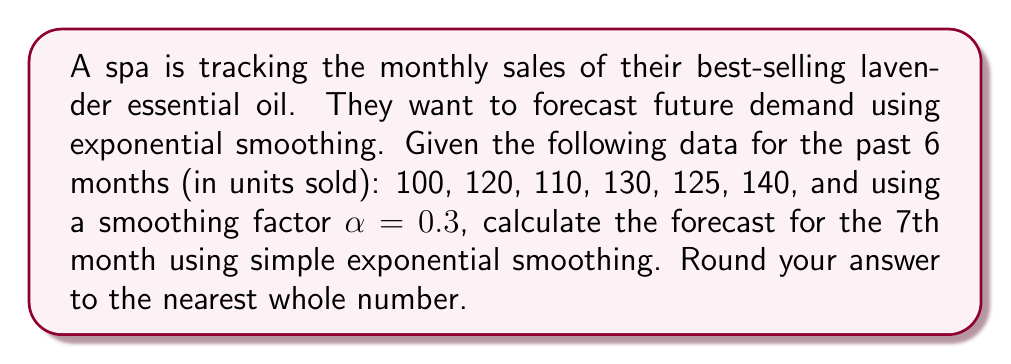What is the answer to this math problem? To forecast future demand using simple exponential smoothing, we use the formula:

$$F_{t+1} = \alpha Y_t + (1-\alpha)F_t$$

Where:
$F_{t+1}$ is the forecast for the next period
$\alpha$ is the smoothing factor (0.3 in this case)
$Y_t$ is the actual value for the current period
$F_t$ is the forecast for the current period

Step 1: Initialize the forecast
We'll use the first actual value as our initial forecast:
$F_1 = 100$

Step 2: Calculate subsequent forecasts
$F_2 = 0.3(100) + 0.7(100) = 100$
$F_3 = 0.3(120) + 0.7(100) = 106$
$F_4 = 0.3(110) + 0.7(106) = 107.2$
$F_5 = 0.3(130) + 0.7(107.2) = 114.04$
$F_6 = 0.3(125) + 0.7(114.04) = 117.328$

Step 3: Calculate the forecast for the 7th month
$F_7 = 0.3(140) + 0.7(117.328) = 124.1296$

Step 4: Round to the nearest whole number
124.1296 rounds to 124
Answer: 124 units 